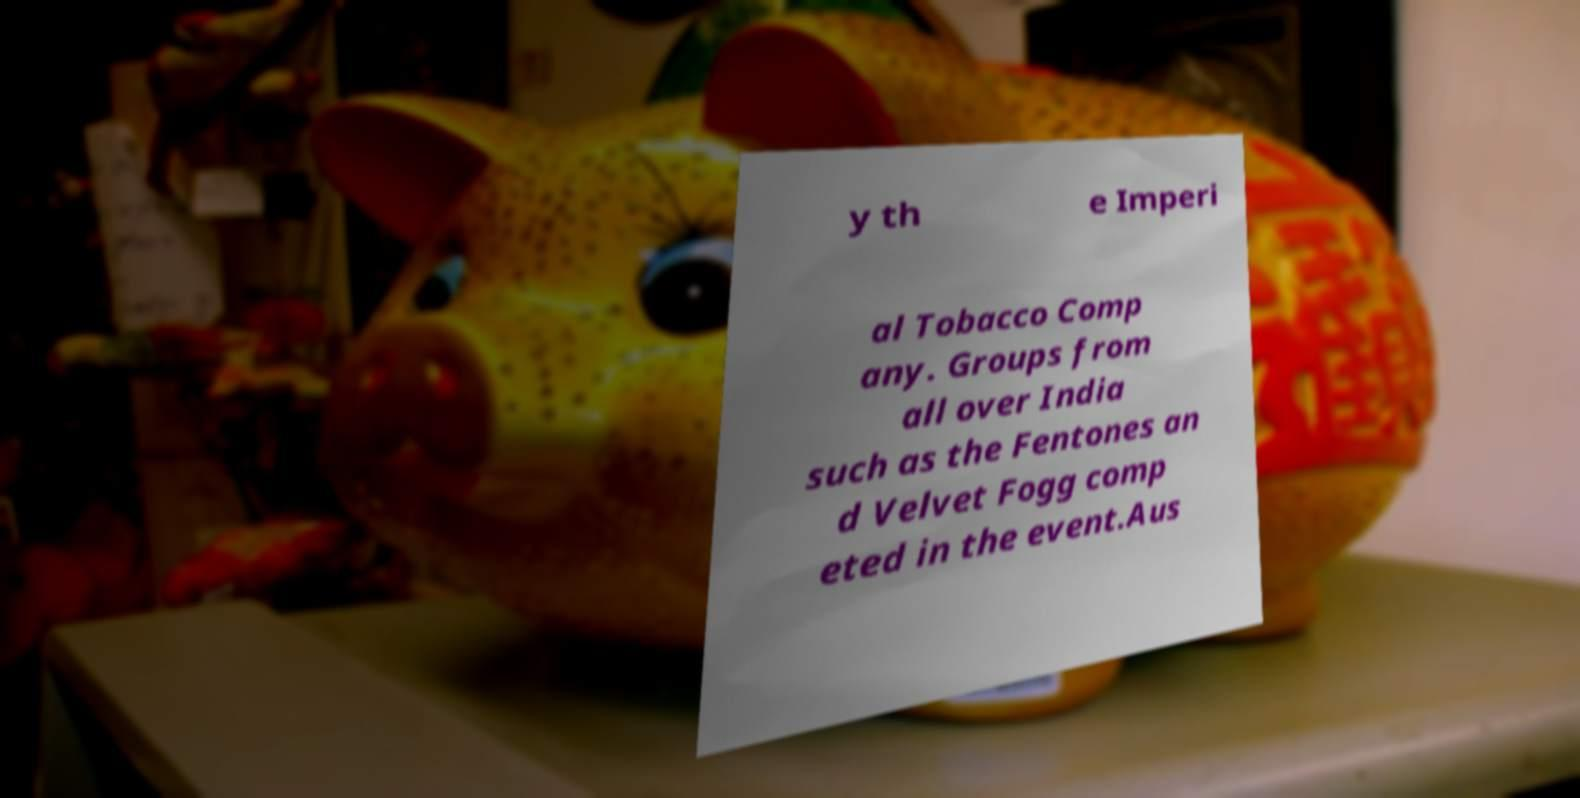Please read and relay the text visible in this image. What does it say? y th e Imperi al Tobacco Comp any. Groups from all over India such as the Fentones an d Velvet Fogg comp eted in the event.Aus 